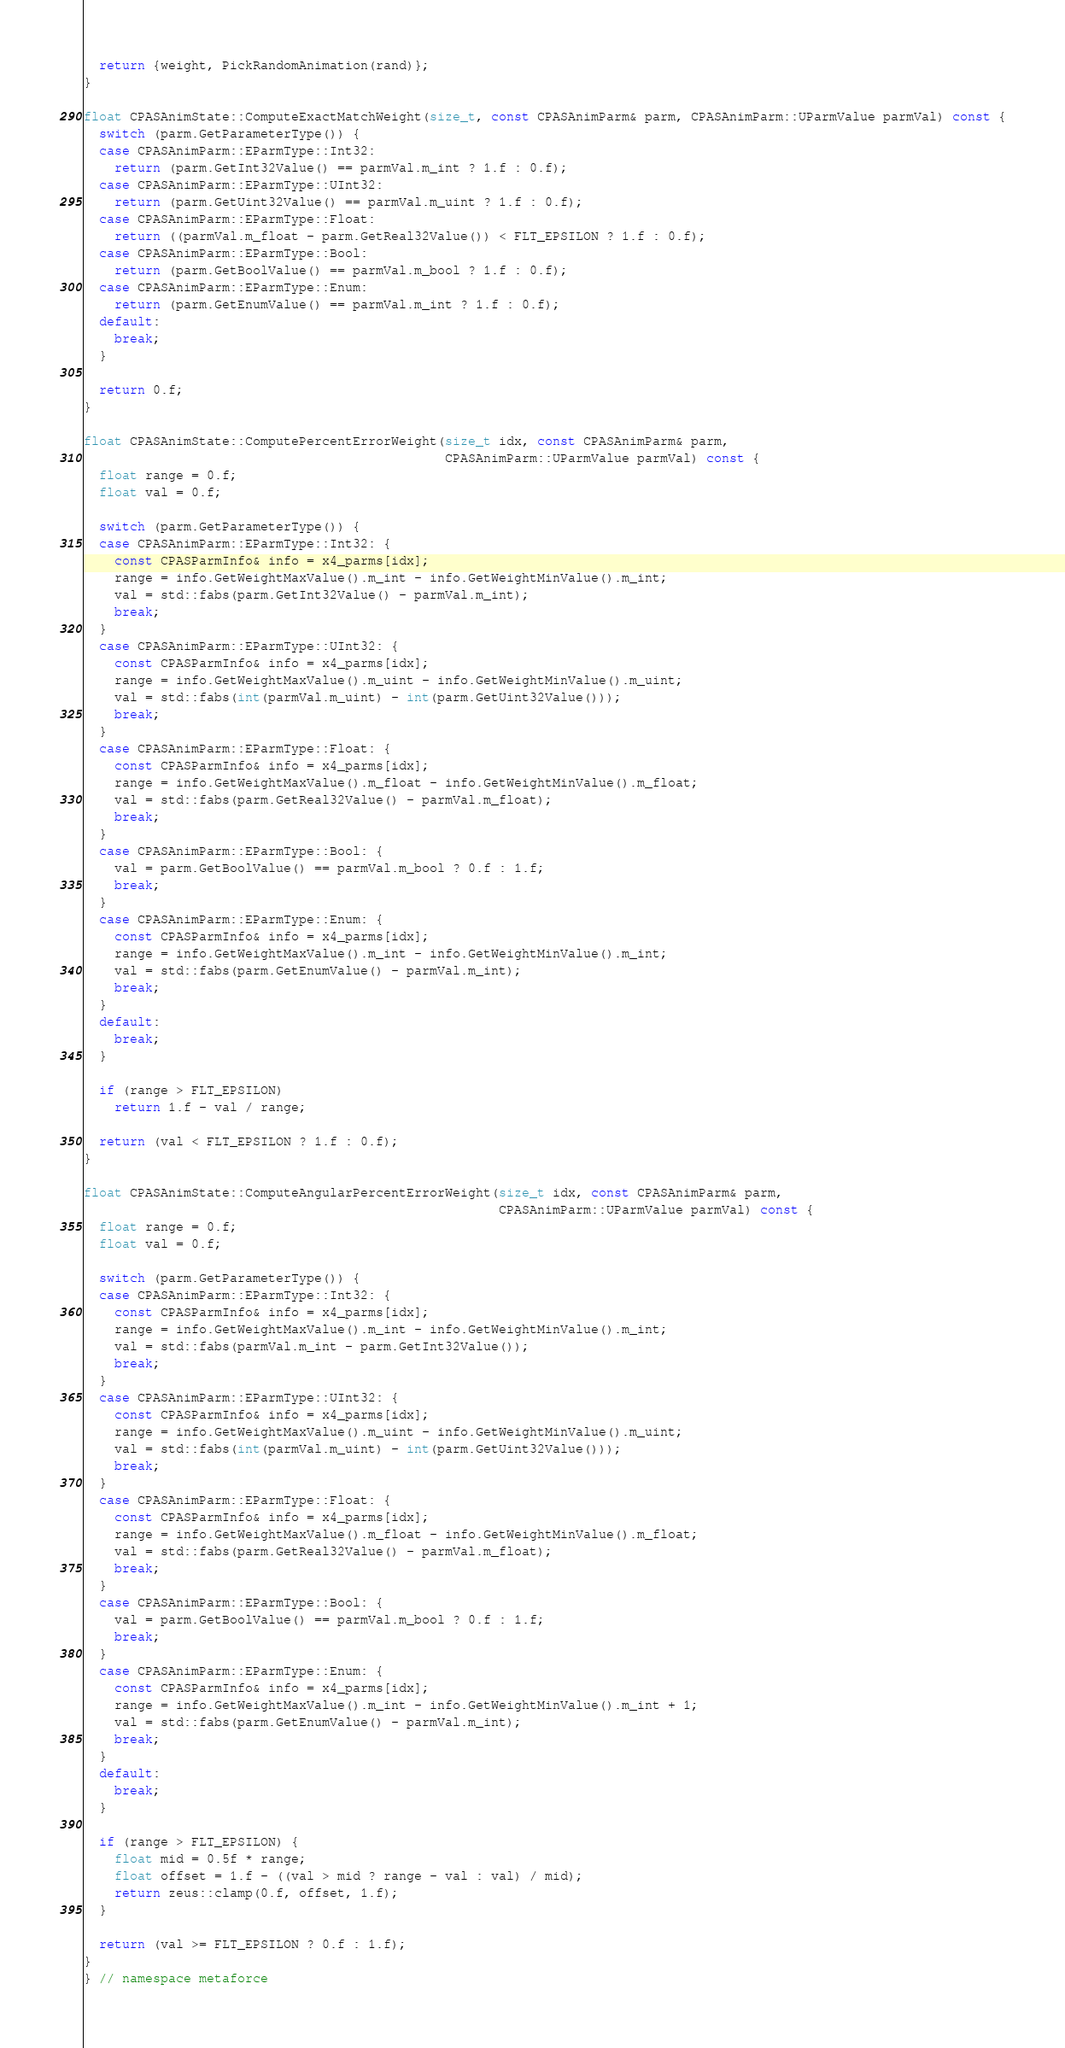Convert code to text. <code><loc_0><loc_0><loc_500><loc_500><_C++_>  return {weight, PickRandomAnimation(rand)};
}

float CPASAnimState::ComputeExactMatchWeight(size_t, const CPASAnimParm& parm, CPASAnimParm::UParmValue parmVal) const {
  switch (parm.GetParameterType()) {
  case CPASAnimParm::EParmType::Int32:
    return (parm.GetInt32Value() == parmVal.m_int ? 1.f : 0.f);
  case CPASAnimParm::EParmType::UInt32:
    return (parm.GetUint32Value() == parmVal.m_uint ? 1.f : 0.f);
  case CPASAnimParm::EParmType::Float:
    return ((parmVal.m_float - parm.GetReal32Value()) < FLT_EPSILON ? 1.f : 0.f);
  case CPASAnimParm::EParmType::Bool:
    return (parm.GetBoolValue() == parmVal.m_bool ? 1.f : 0.f);
  case CPASAnimParm::EParmType::Enum:
    return (parm.GetEnumValue() == parmVal.m_int ? 1.f : 0.f);
  default:
    break;
  }

  return 0.f;
}

float CPASAnimState::ComputePercentErrorWeight(size_t idx, const CPASAnimParm& parm,
                                               CPASAnimParm::UParmValue parmVal) const {
  float range = 0.f;
  float val = 0.f;

  switch (parm.GetParameterType()) {
  case CPASAnimParm::EParmType::Int32: {
    const CPASParmInfo& info = x4_parms[idx];
    range = info.GetWeightMaxValue().m_int - info.GetWeightMinValue().m_int;
    val = std::fabs(parm.GetInt32Value() - parmVal.m_int);
    break;
  }
  case CPASAnimParm::EParmType::UInt32: {
    const CPASParmInfo& info = x4_parms[idx];
    range = info.GetWeightMaxValue().m_uint - info.GetWeightMinValue().m_uint;
    val = std::fabs(int(parmVal.m_uint) - int(parm.GetUint32Value()));
    break;
  }
  case CPASAnimParm::EParmType::Float: {
    const CPASParmInfo& info = x4_parms[idx];
    range = info.GetWeightMaxValue().m_float - info.GetWeightMinValue().m_float;
    val = std::fabs(parm.GetReal32Value() - parmVal.m_float);
    break;
  }
  case CPASAnimParm::EParmType::Bool: {
    val = parm.GetBoolValue() == parmVal.m_bool ? 0.f : 1.f;
    break;
  }
  case CPASAnimParm::EParmType::Enum: {
    const CPASParmInfo& info = x4_parms[idx];
    range = info.GetWeightMaxValue().m_int - info.GetWeightMinValue().m_int;
    val = std::fabs(parm.GetEnumValue() - parmVal.m_int);
    break;
  }
  default:
    break;
  }

  if (range > FLT_EPSILON)
    return 1.f - val / range;

  return (val < FLT_EPSILON ? 1.f : 0.f);
}

float CPASAnimState::ComputeAngularPercentErrorWeight(size_t idx, const CPASAnimParm& parm,
                                                      CPASAnimParm::UParmValue parmVal) const {
  float range = 0.f;
  float val = 0.f;

  switch (parm.GetParameterType()) {
  case CPASAnimParm::EParmType::Int32: {
    const CPASParmInfo& info = x4_parms[idx];
    range = info.GetWeightMaxValue().m_int - info.GetWeightMinValue().m_int;
    val = std::fabs(parmVal.m_int - parm.GetInt32Value());
    break;
  }
  case CPASAnimParm::EParmType::UInt32: {
    const CPASParmInfo& info = x4_parms[idx];
    range = info.GetWeightMaxValue().m_uint - info.GetWeightMinValue().m_uint;
    val = std::fabs(int(parmVal.m_uint) - int(parm.GetUint32Value()));
    break;
  }
  case CPASAnimParm::EParmType::Float: {
    const CPASParmInfo& info = x4_parms[idx];
    range = info.GetWeightMaxValue().m_float - info.GetWeightMinValue().m_float;
    val = std::fabs(parm.GetReal32Value() - parmVal.m_float);
    break;
  }
  case CPASAnimParm::EParmType::Bool: {
    val = parm.GetBoolValue() == parmVal.m_bool ? 0.f : 1.f;
    break;
  }
  case CPASAnimParm::EParmType::Enum: {
    const CPASParmInfo& info = x4_parms[idx];
    range = info.GetWeightMaxValue().m_int - info.GetWeightMinValue().m_int + 1;
    val = std::fabs(parm.GetEnumValue() - parmVal.m_int);
    break;
  }
  default:
    break;
  }

  if (range > FLT_EPSILON) {
    float mid = 0.5f * range;
    float offset = 1.f - ((val > mid ? range - val : val) / mid);
    return zeus::clamp(0.f, offset, 1.f);
  }

  return (val >= FLT_EPSILON ? 0.f : 1.f);
}
} // namespace metaforce
</code> 